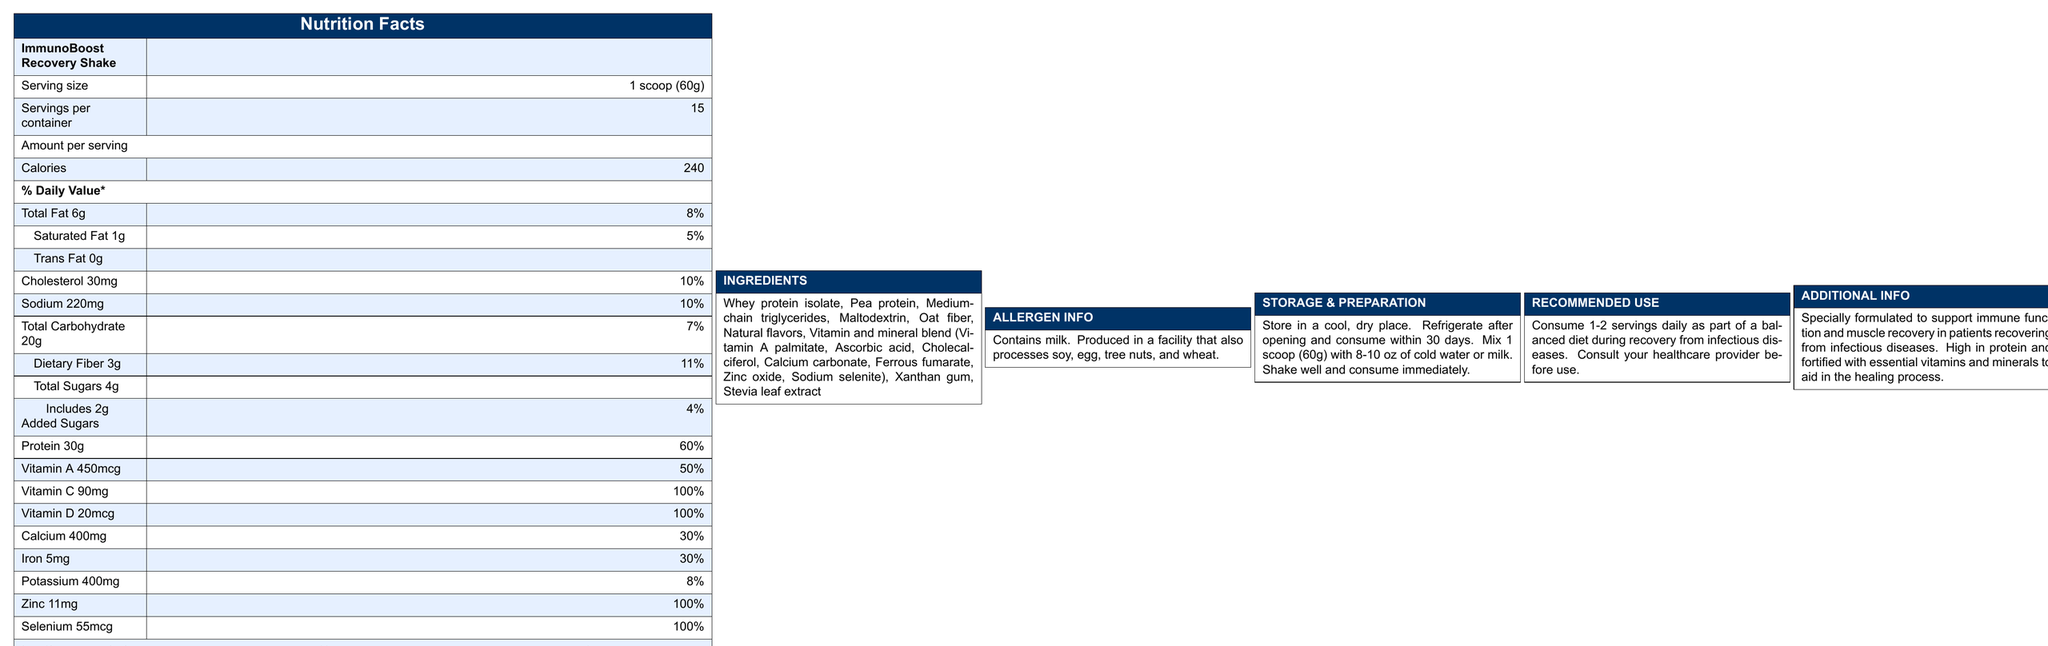what is the serving size? The document lists the serving size as "1 scoop (60g)" under the "ImmunoBoost Recovery Shake" heading.
Answer: 1 scoop (60g) how many calories are in one serving? The document states that the amount per serving includes 240 calories.
Answer: 240 what percentage of the daily value is the protein content? The protein content per serving is listed as 30g, which is 60% of the daily value.
Answer: 60% how much dietary fiber does one serving contain? According to the document, one serving contains 3g of dietary fiber, which is 11% of the daily value.
Answer: 3g how much iron is in one serving? The document specifies that one serving contains 5mg of iron, which is 30% of the daily value.
Answer: 5mg which vitamin provides 100% of the daily value per serving? A. Vitamin A B. Vitamin C C. Vitamin E D. Vitamin D The document lists Vitamin D at 20mcg per serving, which provides 100% of the daily value.
Answer: D. Vitamin D what is the serving per container? A. 10 B. 12 C. 15 D. 20 The document states that there are 15 servings per container.
Answer: C. 15 does the shake contain any trans fat? The document shows that the amount of trans fat per serving is 0g.
Answer: No is this product allergen-free? The allergen information section of the document indicates that the product contains milk and is produced in a facility that also processes soy, egg, tree nuts, and wheat.
Answer: No describe the main idea of this document. The document features a comprehensive description of the nutritional content of the shake, its ingredients, allergen warnings, instructions for use and storage, and its purpose in aiding recovery from infectious diseases.
Answer: The document provides detailed nutritional information for the "ImmunoBoost Recovery Shake," including serving size, calorie count, and the amounts of various nutrients per serving. It specifies key ingredients, allergen information, storage and preparation instructions, recommended use, and additional information on how the product supports immune function and muscle recovery for patients recovering from infectious diseases. what is the sugar content per serving? The total sugar content per serving is listed as 4g in the document.
Answer: 4g how should the shake be stored after opening? The storage instructions in the document state that the shake should be refrigerated after opening and consumed within 30 days.
Answer: Refrigerate after opening and consume within 30 days how much calcium is in one serving? The document indicates that one serving contains 400mg of calcium, which is 30% of the daily value.
Answer: 400mg what amount of vitamin A is in one serving? Per the document, one serving includes 450mcg of vitamin A, which is 50% of the daily value.
Answer: 450mcg can you determine the flavor of the shake from the document? While the document lists "Natural flavors" as an ingredient, it does not provide specific details about the flavor of the shake.
Answer: Not enough information 